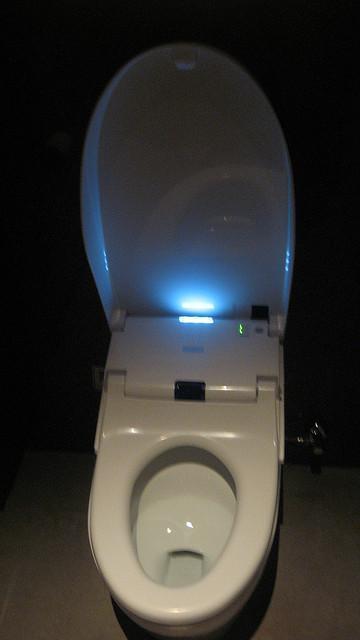How many lights are on this toilet?
Give a very brief answer. 1. How many toilets can be seen?
Give a very brief answer. 1. 